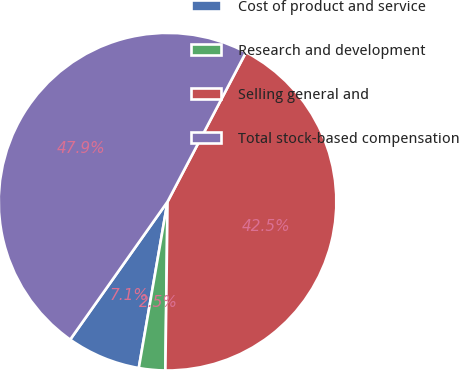Convert chart. <chart><loc_0><loc_0><loc_500><loc_500><pie_chart><fcel>Cost of product and service<fcel>Research and development<fcel>Selling general and<fcel>Total stock-based compensation<nl><fcel>7.06%<fcel>2.52%<fcel>42.51%<fcel>47.91%<nl></chart> 